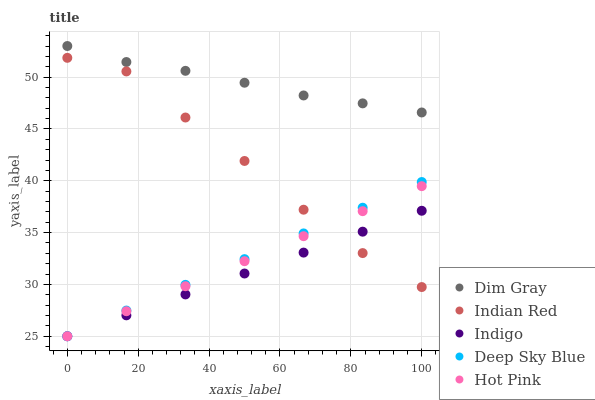Does Indigo have the minimum area under the curve?
Answer yes or no. Yes. Does Dim Gray have the maximum area under the curve?
Answer yes or no. Yes. Does Deep Sky Blue have the minimum area under the curve?
Answer yes or no. No. Does Deep Sky Blue have the maximum area under the curve?
Answer yes or no. No. Is Indigo the smoothest?
Answer yes or no. Yes. Is Indian Red the roughest?
Answer yes or no. Yes. Is Deep Sky Blue the smoothest?
Answer yes or no. No. Is Deep Sky Blue the roughest?
Answer yes or no. No. Does Indigo have the lowest value?
Answer yes or no. Yes. Does Indian Red have the lowest value?
Answer yes or no. No. Does Dim Gray have the highest value?
Answer yes or no. Yes. Does Deep Sky Blue have the highest value?
Answer yes or no. No. Is Indian Red less than Dim Gray?
Answer yes or no. Yes. Is Dim Gray greater than Indian Red?
Answer yes or no. Yes. Does Hot Pink intersect Indian Red?
Answer yes or no. Yes. Is Hot Pink less than Indian Red?
Answer yes or no. No. Is Hot Pink greater than Indian Red?
Answer yes or no. No. Does Indian Red intersect Dim Gray?
Answer yes or no. No. 